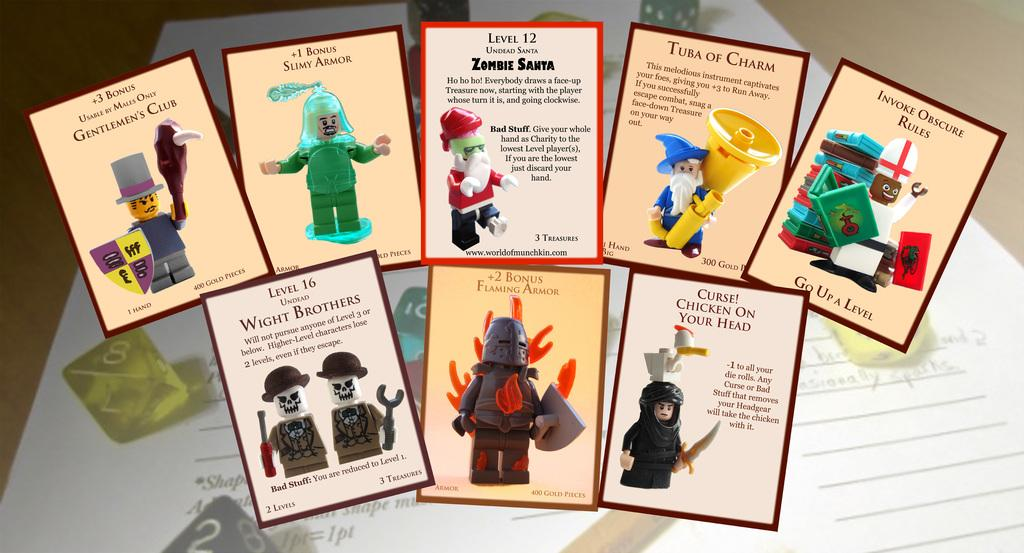Provide a one-sentence caption for the provided image. Several cards feature Lego characters, including Level 12, Zombie Santa. 